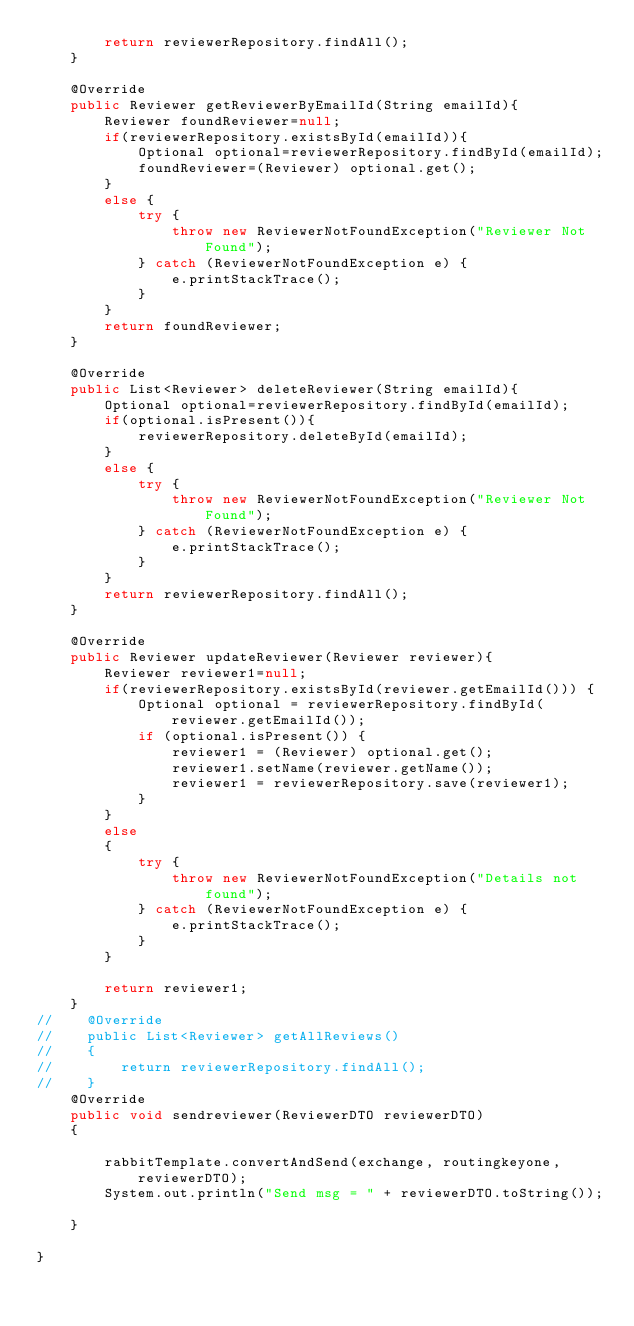Convert code to text. <code><loc_0><loc_0><loc_500><loc_500><_Java_>        return reviewerRepository.findAll();
    }

    @Override
    public Reviewer getReviewerByEmailId(String emailId){
        Reviewer foundReviewer=null;
        if(reviewerRepository.existsById(emailId)){
            Optional optional=reviewerRepository.findById(emailId);
            foundReviewer=(Reviewer) optional.get();
        }
        else {
            try {
                throw new ReviewerNotFoundException("Reviewer Not Found");
            } catch (ReviewerNotFoundException e) {
                e.printStackTrace();
            }
        }
        return foundReviewer;
    }

    @Override
    public List<Reviewer> deleteReviewer(String emailId){
        Optional optional=reviewerRepository.findById(emailId);
        if(optional.isPresent()){
            reviewerRepository.deleteById(emailId);
        }
        else {
            try {
                throw new ReviewerNotFoundException("Reviewer Not Found");
            } catch (ReviewerNotFoundException e) {
                e.printStackTrace();
            }
        }
        return reviewerRepository.findAll();
    }

    @Override
    public Reviewer updateReviewer(Reviewer reviewer){
        Reviewer reviewer1=null;
        if(reviewerRepository.existsById(reviewer.getEmailId())) {
            Optional optional = reviewerRepository.findById(reviewer.getEmailId());
            if (optional.isPresent()) {
                reviewer1 = (Reviewer) optional.get();
                reviewer1.setName(reviewer.getName());
                reviewer1 = reviewerRepository.save(reviewer1);
            }
        }
        else
        {
            try {
                throw new ReviewerNotFoundException("Details not found");
            } catch (ReviewerNotFoundException e) {
                e.printStackTrace();
            }
        }

        return reviewer1;
    }
//    @Override
//    public List<Reviewer> getAllReviews()
//    {
//        return reviewerRepository.findAll();
//    }
    @Override
    public void sendreviewer(ReviewerDTO reviewerDTO)
    {

        rabbitTemplate.convertAndSend(exchange, routingkeyone, reviewerDTO);
        System.out.println("Send msg = " + reviewerDTO.toString());

    }

}
</code> 